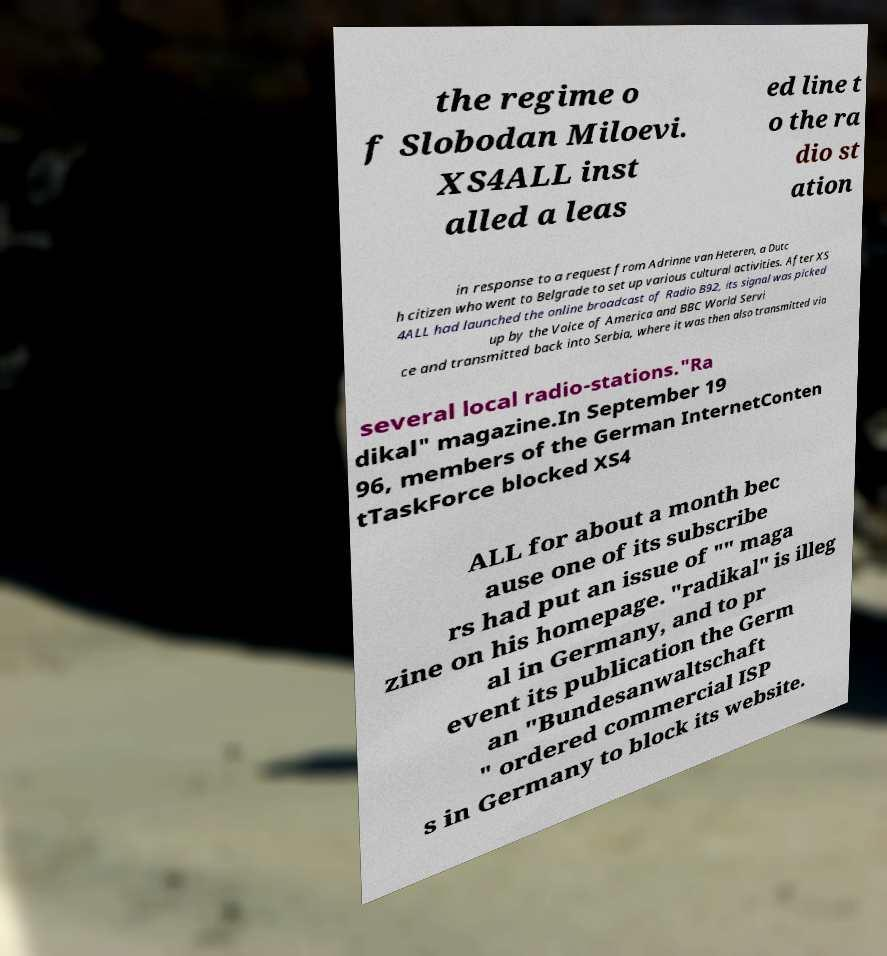Could you extract and type out the text from this image? the regime o f Slobodan Miloevi. XS4ALL inst alled a leas ed line t o the ra dio st ation in response to a request from Adrinne van Heteren, a Dutc h citizen who went to Belgrade to set up various cultural activities. After XS 4ALL had launched the online broadcast of Radio B92, its signal was picked up by the Voice of America and BBC World Servi ce and transmitted back into Serbia, where it was then also transmitted via several local radio-stations."Ra dikal" magazine.In September 19 96, members of the German InternetConten tTaskForce blocked XS4 ALL for about a month bec ause one of its subscribe rs had put an issue of "" maga zine on his homepage. "radikal" is illeg al in Germany, and to pr event its publication the Germ an "Bundesanwaltschaft " ordered commercial ISP s in Germany to block its website. 